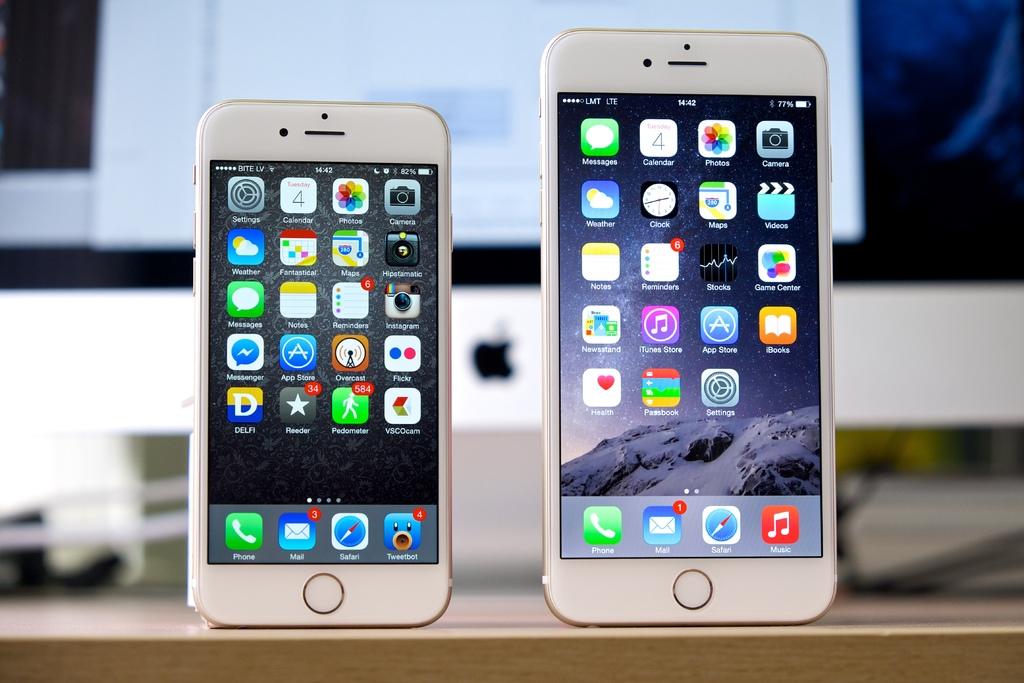What is the time shown onthe phone on the right?
Provide a succinct answer. 14:42. How many emails does the phone on the left have?
Your response must be concise. 3. 